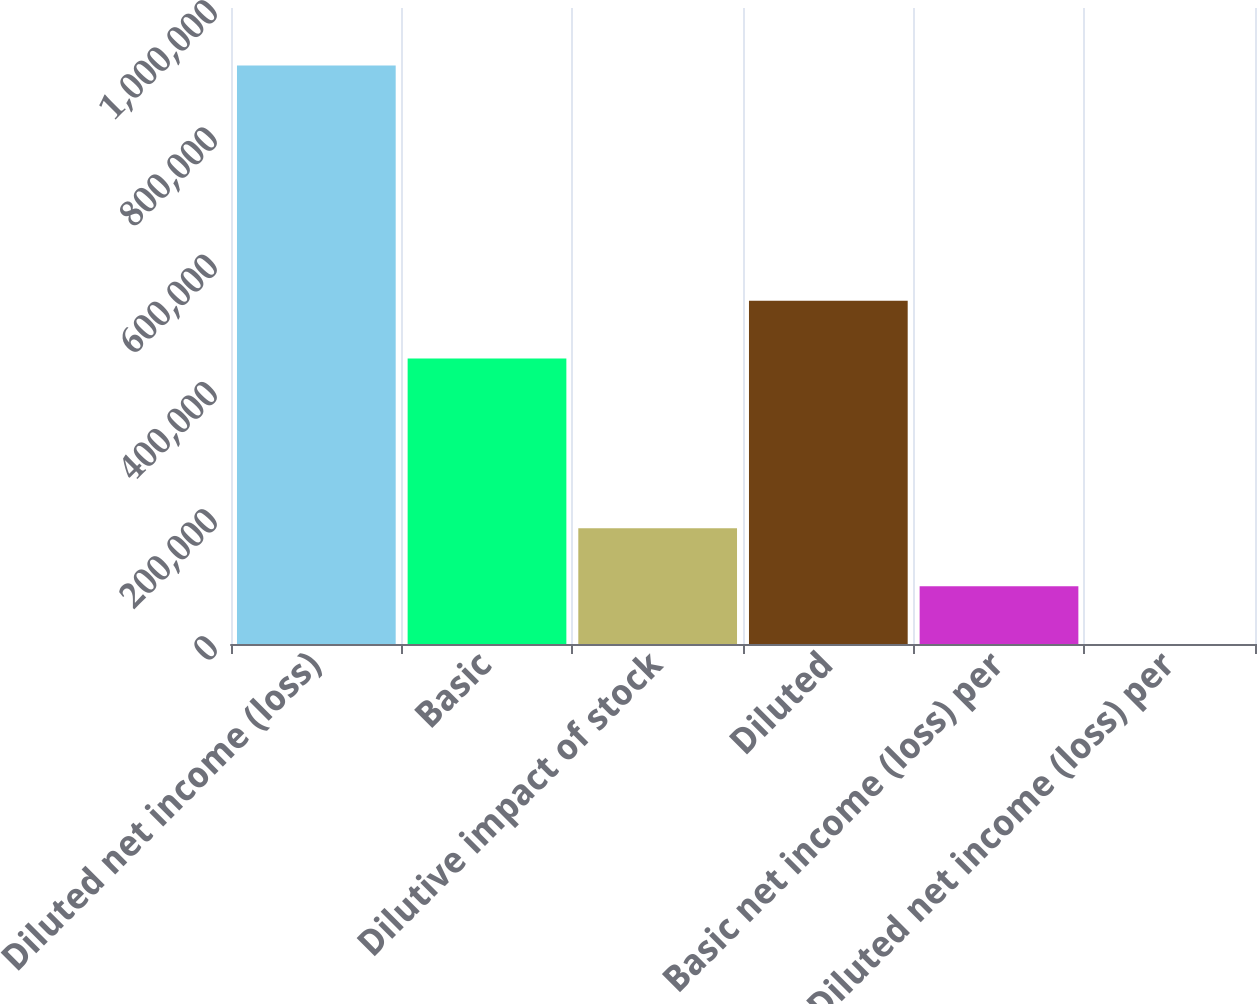<chart> <loc_0><loc_0><loc_500><loc_500><bar_chart><fcel>Diluted net income (loss)<fcel>Basic<fcel>Dilutive impact of stock<fcel>Diluted<fcel>Basic net income (loss) per<fcel>Diluted net income (loss) per<nl><fcel>909585<fcel>448786<fcel>181919<fcel>539744<fcel>90960.3<fcel>1.98<nl></chart> 